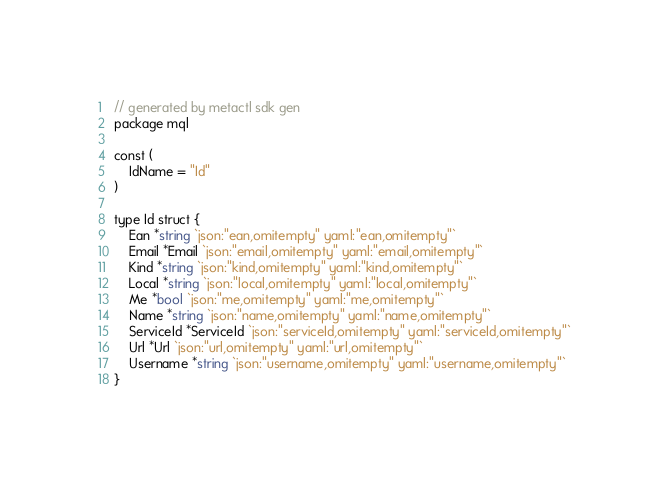Convert code to text. <code><loc_0><loc_0><loc_500><loc_500><_Go_>// generated by metactl sdk gen 
package mql

const (
	IdName = "Id"
)

type Id struct {
    Ean *string `json:"ean,omitempty" yaml:"ean,omitempty"`
    Email *Email `json:"email,omitempty" yaml:"email,omitempty"`
    Kind *string `json:"kind,omitempty" yaml:"kind,omitempty"`
    Local *string `json:"local,omitempty" yaml:"local,omitempty"`
    Me *bool `json:"me,omitempty" yaml:"me,omitempty"`
    Name *string `json:"name,omitempty" yaml:"name,omitempty"`
    ServiceId *ServiceId `json:"serviceId,omitempty" yaml:"serviceId,omitempty"`
    Url *Url `json:"url,omitempty" yaml:"url,omitempty"`
    Username *string `json:"username,omitempty" yaml:"username,omitempty"`
}</code> 